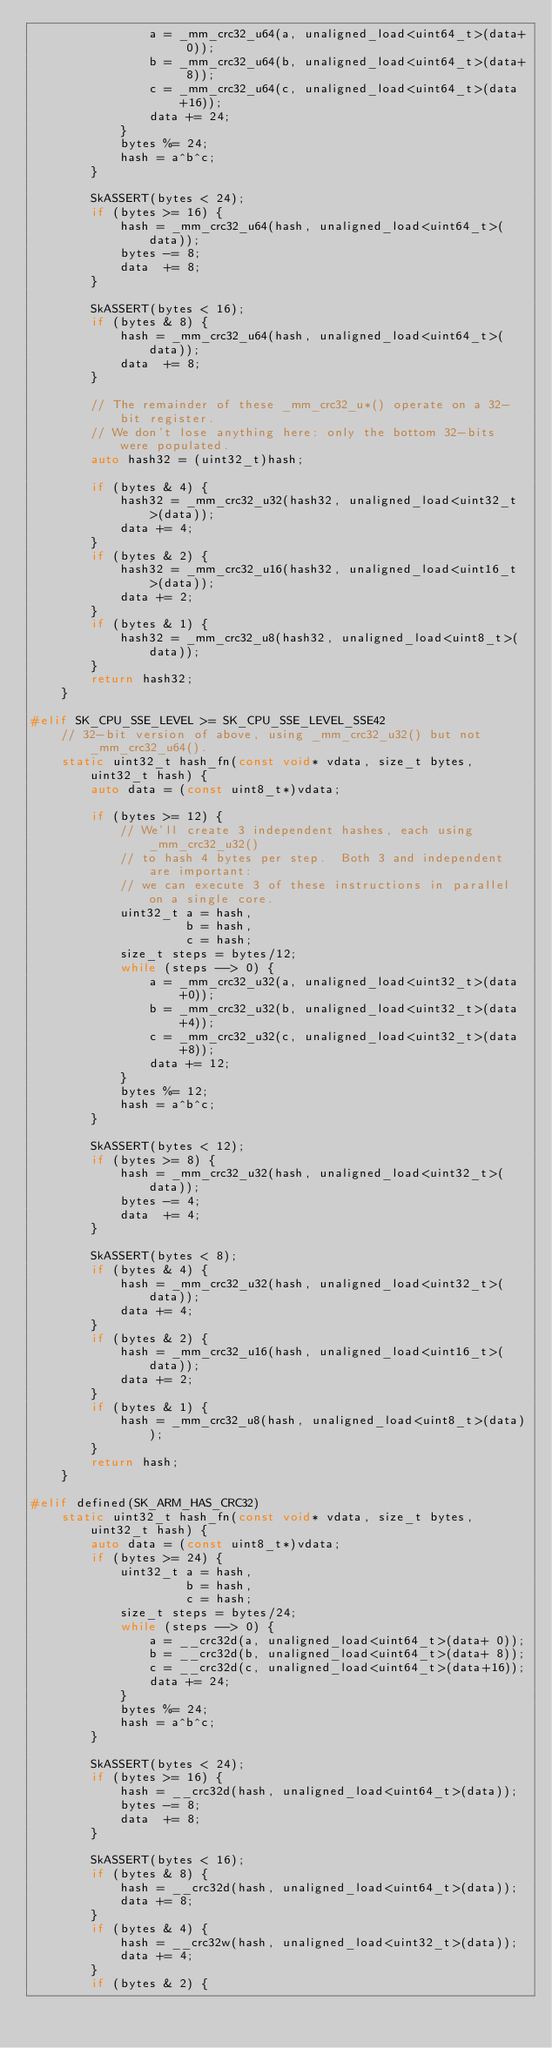Convert code to text. <code><loc_0><loc_0><loc_500><loc_500><_C_>                a = _mm_crc32_u64(a, unaligned_load<uint64_t>(data+ 0));
                b = _mm_crc32_u64(b, unaligned_load<uint64_t>(data+ 8));
                c = _mm_crc32_u64(c, unaligned_load<uint64_t>(data+16));
                data += 24;
            }
            bytes %= 24;
            hash = a^b^c;
        }

        SkASSERT(bytes < 24);
        if (bytes >= 16) {
            hash = _mm_crc32_u64(hash, unaligned_load<uint64_t>(data));
            bytes -= 8;
            data  += 8;
        }

        SkASSERT(bytes < 16);
        if (bytes & 8) {
            hash = _mm_crc32_u64(hash, unaligned_load<uint64_t>(data));
            data  += 8;
        }

        // The remainder of these _mm_crc32_u*() operate on a 32-bit register.
        // We don't lose anything here: only the bottom 32-bits were populated.
        auto hash32 = (uint32_t)hash;

        if (bytes & 4) {
            hash32 = _mm_crc32_u32(hash32, unaligned_load<uint32_t>(data));
            data += 4;
        }
        if (bytes & 2) {
            hash32 = _mm_crc32_u16(hash32, unaligned_load<uint16_t>(data));
            data += 2;
        }
        if (bytes & 1) {
            hash32 = _mm_crc32_u8(hash32, unaligned_load<uint8_t>(data));
        }
        return hash32;
    }

#elif SK_CPU_SSE_LEVEL >= SK_CPU_SSE_LEVEL_SSE42
    // 32-bit version of above, using _mm_crc32_u32() but not _mm_crc32_u64().
    static uint32_t hash_fn(const void* vdata, size_t bytes, uint32_t hash) {
        auto data = (const uint8_t*)vdata;

        if (bytes >= 12) {
            // We'll create 3 independent hashes, each using _mm_crc32_u32()
            // to hash 4 bytes per step.  Both 3 and independent are important:
            // we can execute 3 of these instructions in parallel on a single core.
            uint32_t a = hash,
                     b = hash,
                     c = hash;
            size_t steps = bytes/12;
            while (steps --> 0) {
                a = _mm_crc32_u32(a, unaligned_load<uint32_t>(data+0));
                b = _mm_crc32_u32(b, unaligned_load<uint32_t>(data+4));
                c = _mm_crc32_u32(c, unaligned_load<uint32_t>(data+8));
                data += 12;
            }
            bytes %= 12;
            hash = a^b^c;
        }

        SkASSERT(bytes < 12);
        if (bytes >= 8) {
            hash = _mm_crc32_u32(hash, unaligned_load<uint32_t>(data));
            bytes -= 4;
            data  += 4;
        }

        SkASSERT(bytes < 8);
        if (bytes & 4) {
            hash = _mm_crc32_u32(hash, unaligned_load<uint32_t>(data));
            data += 4;
        }
        if (bytes & 2) {
            hash = _mm_crc32_u16(hash, unaligned_load<uint16_t>(data));
            data += 2;
        }
        if (bytes & 1) {
            hash = _mm_crc32_u8(hash, unaligned_load<uint8_t>(data));
        }
        return hash;
    }

#elif defined(SK_ARM_HAS_CRC32)
    static uint32_t hash_fn(const void* vdata, size_t bytes, uint32_t hash) {
        auto data = (const uint8_t*)vdata;
        if (bytes >= 24) {
            uint32_t a = hash,
                     b = hash,
                     c = hash;
            size_t steps = bytes/24;
            while (steps --> 0) {
                a = __crc32d(a, unaligned_load<uint64_t>(data+ 0));
                b = __crc32d(b, unaligned_load<uint64_t>(data+ 8));
                c = __crc32d(c, unaligned_load<uint64_t>(data+16));
                data += 24;
            }
            bytes %= 24;
            hash = a^b^c;
        }

        SkASSERT(bytes < 24);
        if (bytes >= 16) {
            hash = __crc32d(hash, unaligned_load<uint64_t>(data));
            bytes -= 8;
            data  += 8;
        }

        SkASSERT(bytes < 16);
        if (bytes & 8) {
            hash = __crc32d(hash, unaligned_load<uint64_t>(data));
            data += 8;
        }
        if (bytes & 4) {
            hash = __crc32w(hash, unaligned_load<uint32_t>(data));
            data += 4;
        }
        if (bytes & 2) {</code> 